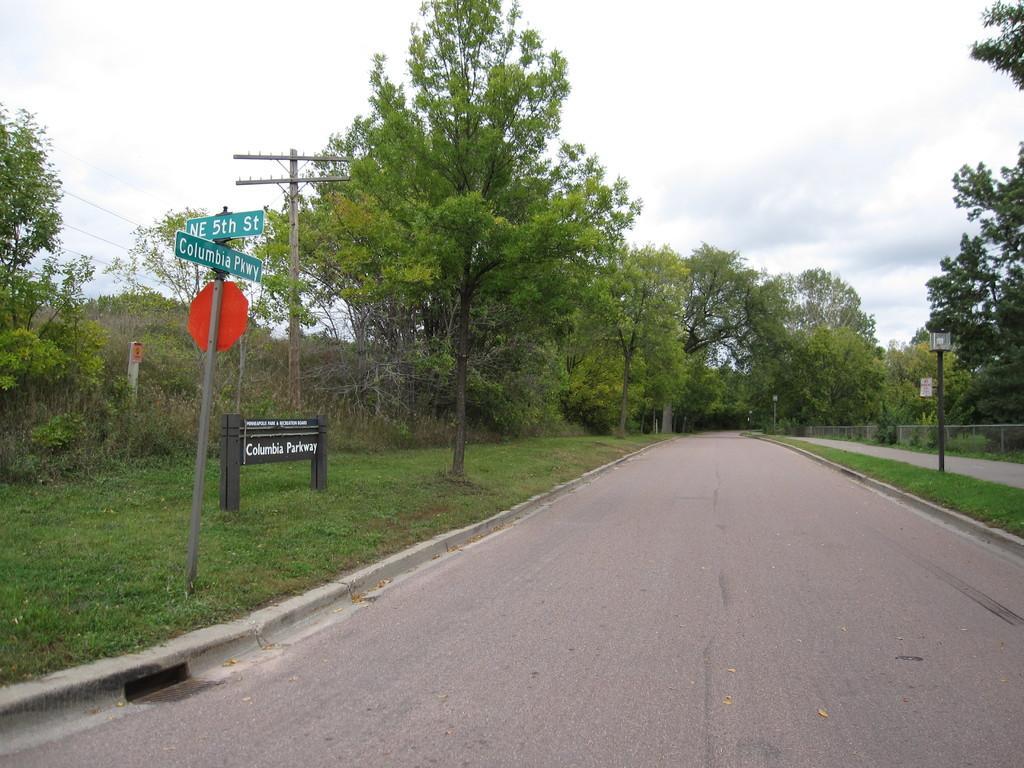Can you describe this image briefly? In this image, we can see a road in between trees. There is a sign board and pole on the left side of the image. There is an another pole on the right side of the image. In the background of the image, there is a sky. 